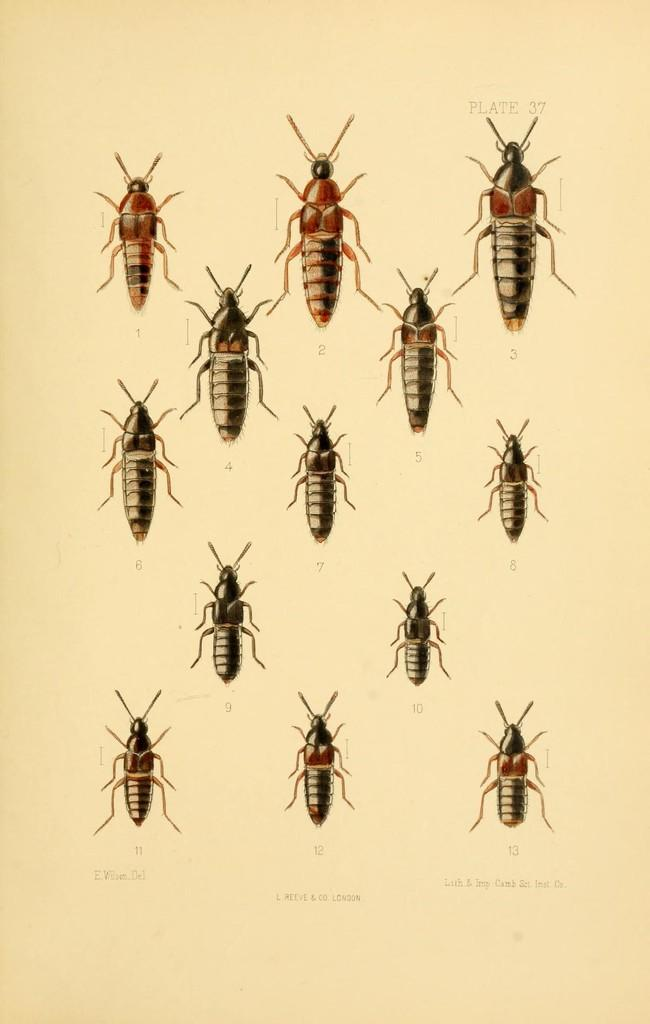What type of creatures can be seen in the image? There are insects in the image. What else is present in the image besides the insects? There is text on a page in the image. What type of mask is being worn by the insect in the image? There are no insects wearing masks in the image. How many cherries can be seen on the page in the image? There are no cherries present in the image. 